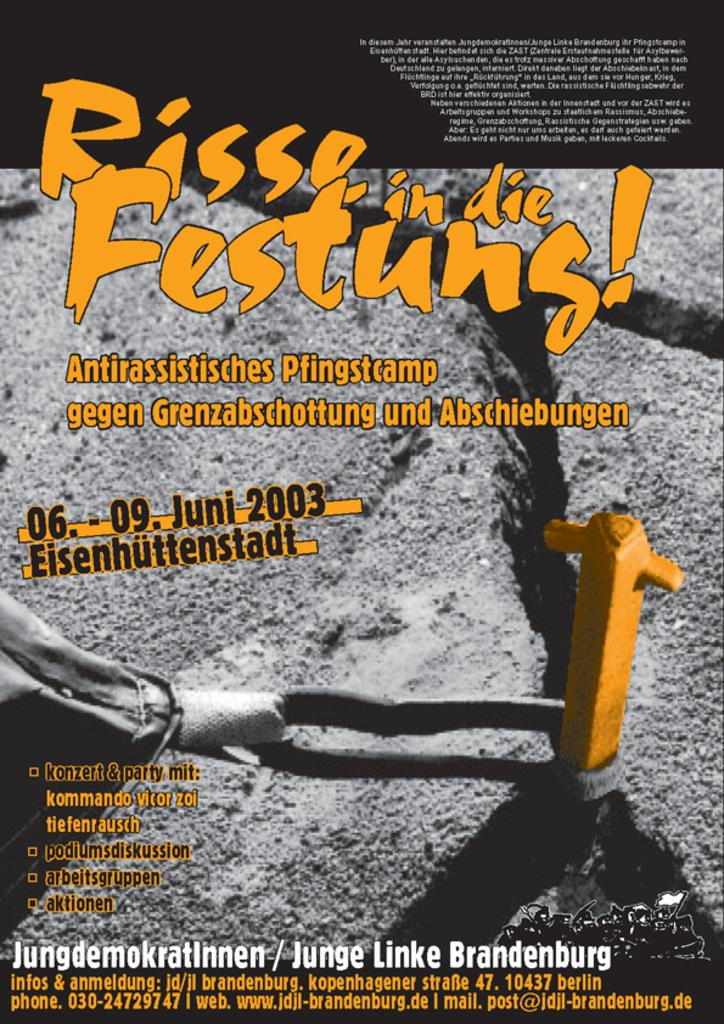What object is in the center of the picture? There is a palm plate in the picture. What can be seen on the right side of the picture? There is a yellow color pole on the right side of the picture. What is written on the palm plate? There is text on the palm plate. What color is the text on the palm plate? The text is in yellow color. What letter is being delivered by the mail carrier in the image? There is no mail carrier or letter present in the image. 